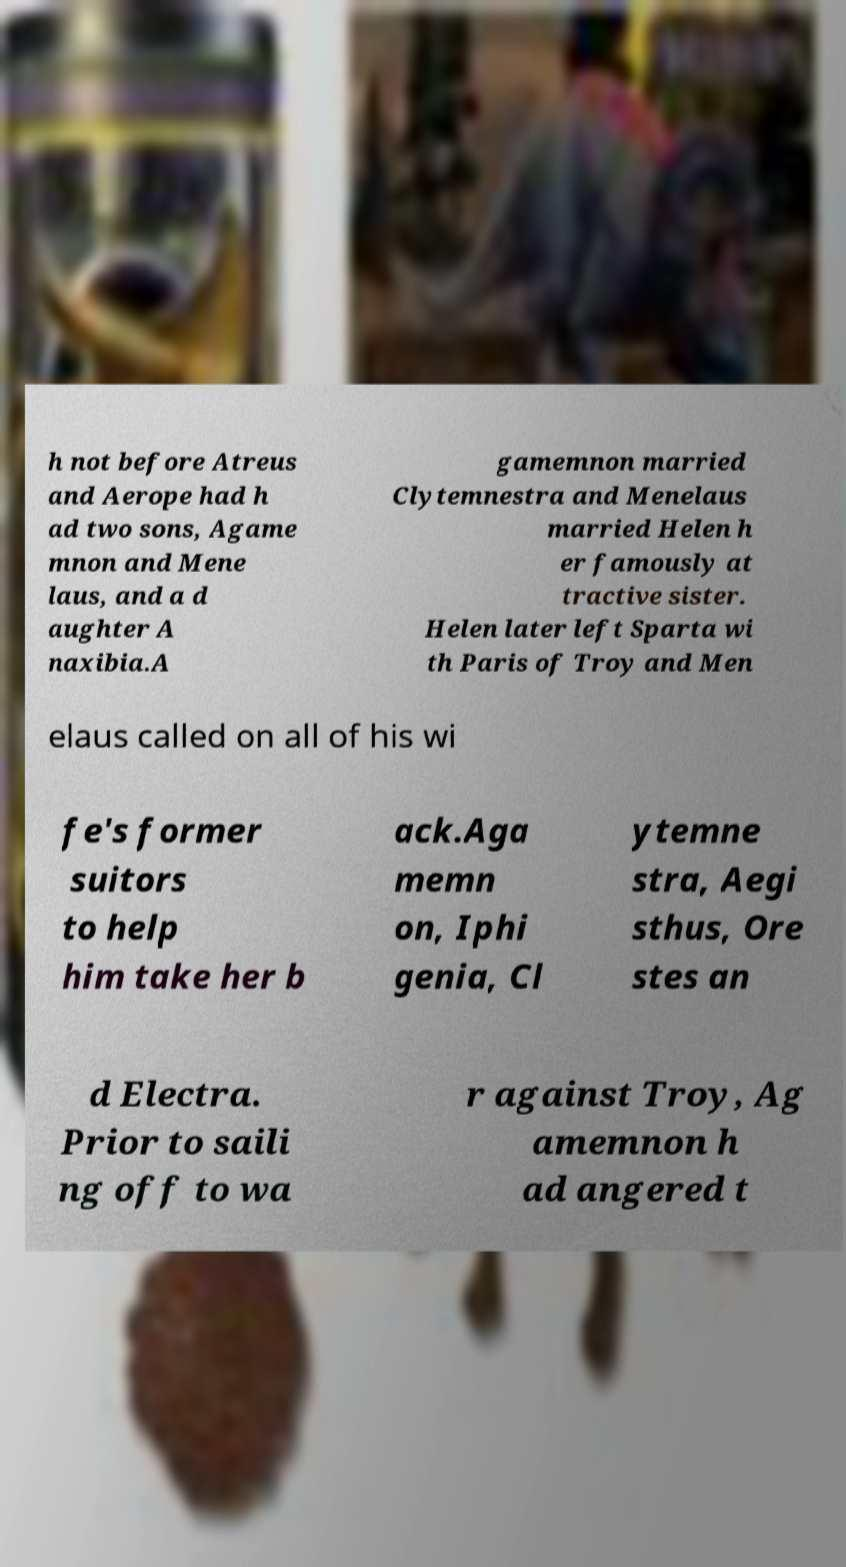Could you assist in decoding the text presented in this image and type it out clearly? h not before Atreus and Aerope had h ad two sons, Agame mnon and Mene laus, and a d aughter A naxibia.A gamemnon married Clytemnestra and Menelaus married Helen h er famously at tractive sister. Helen later left Sparta wi th Paris of Troy and Men elaus called on all of his wi fe's former suitors to help him take her b ack.Aga memn on, Iphi genia, Cl ytemne stra, Aegi sthus, Ore stes an d Electra. Prior to saili ng off to wa r against Troy, Ag amemnon h ad angered t 